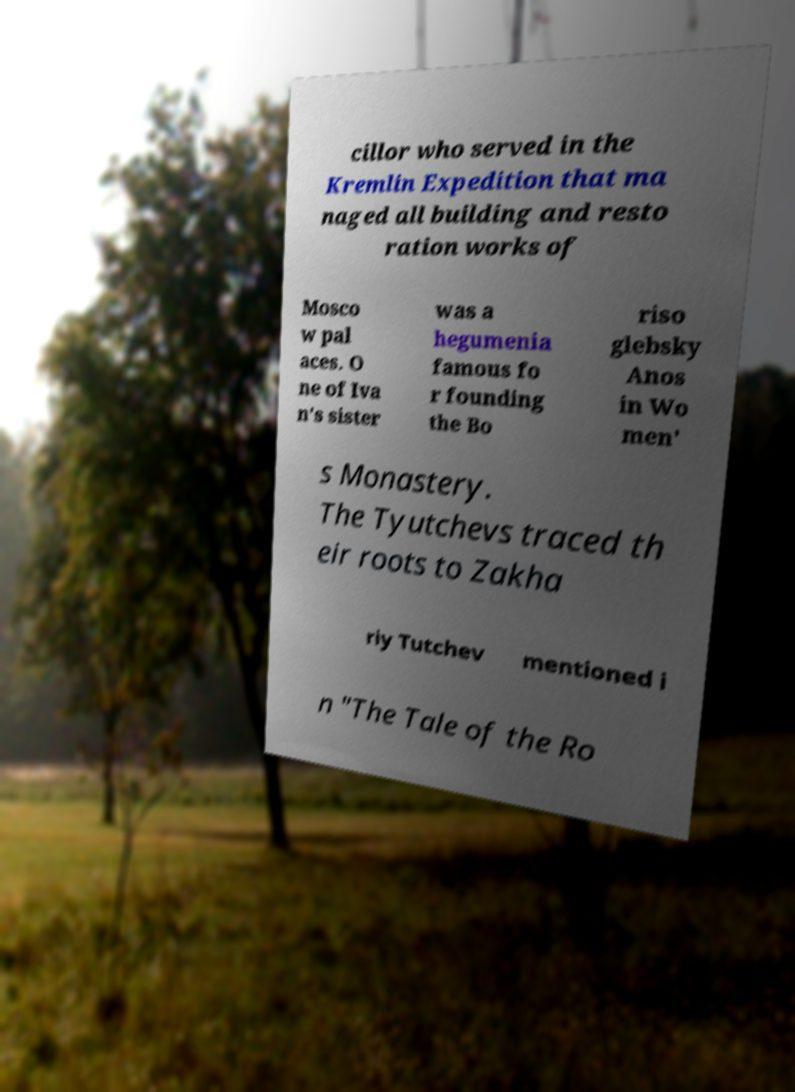Could you extract and type out the text from this image? cillor who served in the Kremlin Expedition that ma naged all building and resto ration works of Mosco w pal aces. O ne of Iva n's sister was a hegumenia famous fo r founding the Bo riso glebsky Anos in Wo men' s Monastery. The Tyutchevs traced th eir roots to Zakha riy Tutchev mentioned i n "The Tale of the Ro 